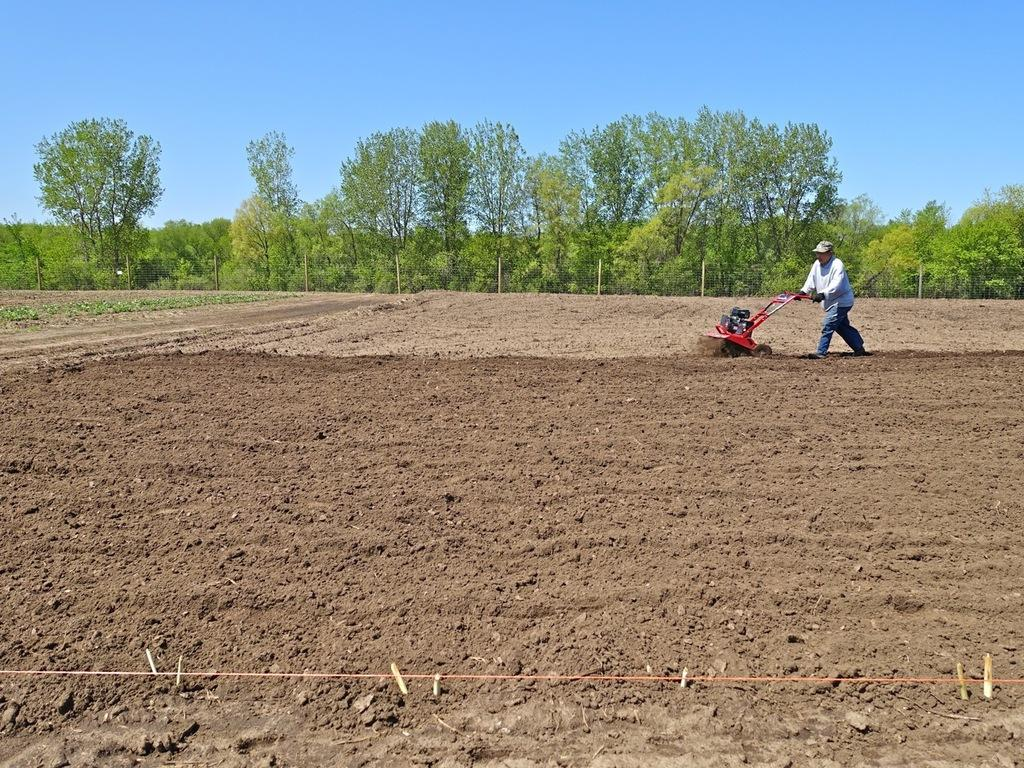What type of terrain is visible in the image? There is a field with soil in the image. What is the person in the image doing? The person is holding an object in the image. What type of vegetation can be seen in the image? There are trees in the image. What type of barrier is present in the image? There is fencing in the image. What is visible in the background of the image? The sky is visible in the background of the image. What type of bells can be heard ringing in the image? There are no bells present in the image, and therefore no sound can be heard. How many giants are visible in the image? There are no giants present in the image. 